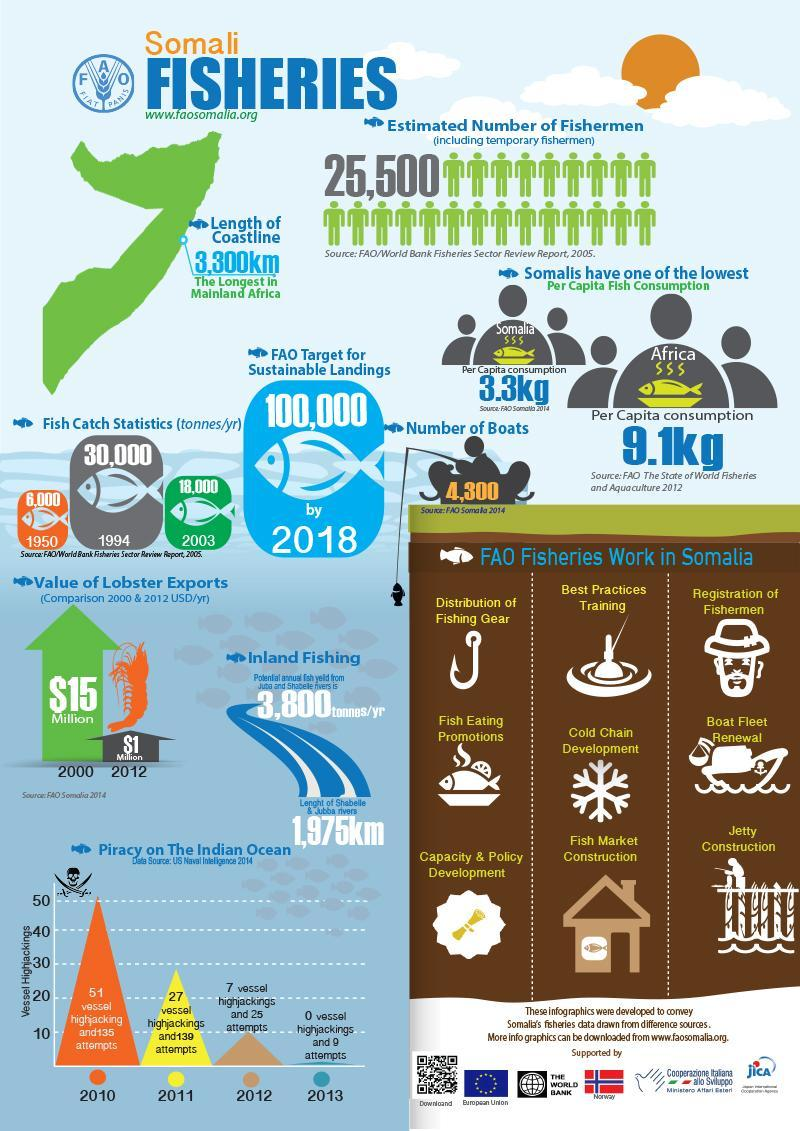Which year in Somalia reported zero vessel hijackings according to the US Naval Intelligence 2014?
Answer the question with a short phrase. 2013 What is the number of fish catches (tonnes/yr) in Somalia in 2003? 18,000 Which year in Somalia reported  27 vessel hijackings according to the US Naval Intelligence 2014? 2011 What is the value of lobster export (in USD/yr) in Somalia in the year 2012? $1 Milllion What is the number of fish catches (tonnes/yr) in Somalia in 1994? 30,000 What is the per capita fish consumption in Somalia according to FAO Somalia 2014? 3.3kg How many vessel hijacking attempts were reported in 2010 in Somalia according to the US Naval Intelligence 2014? 135 How many vessel hijacking attempts were reported in 2011 in Somalia according to the US Naval Intelligence 2014? 139 What is the number of boats in Somalia as per FAO Somalia 2014? 4,300 What is the value of lobster export (in USD/yr) in Somalia in the year 2000? $15 Million 